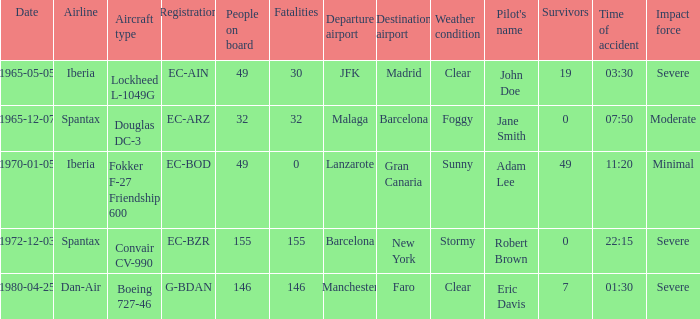How many fatalities shows for the lockheed l-1049g? 30.0. 